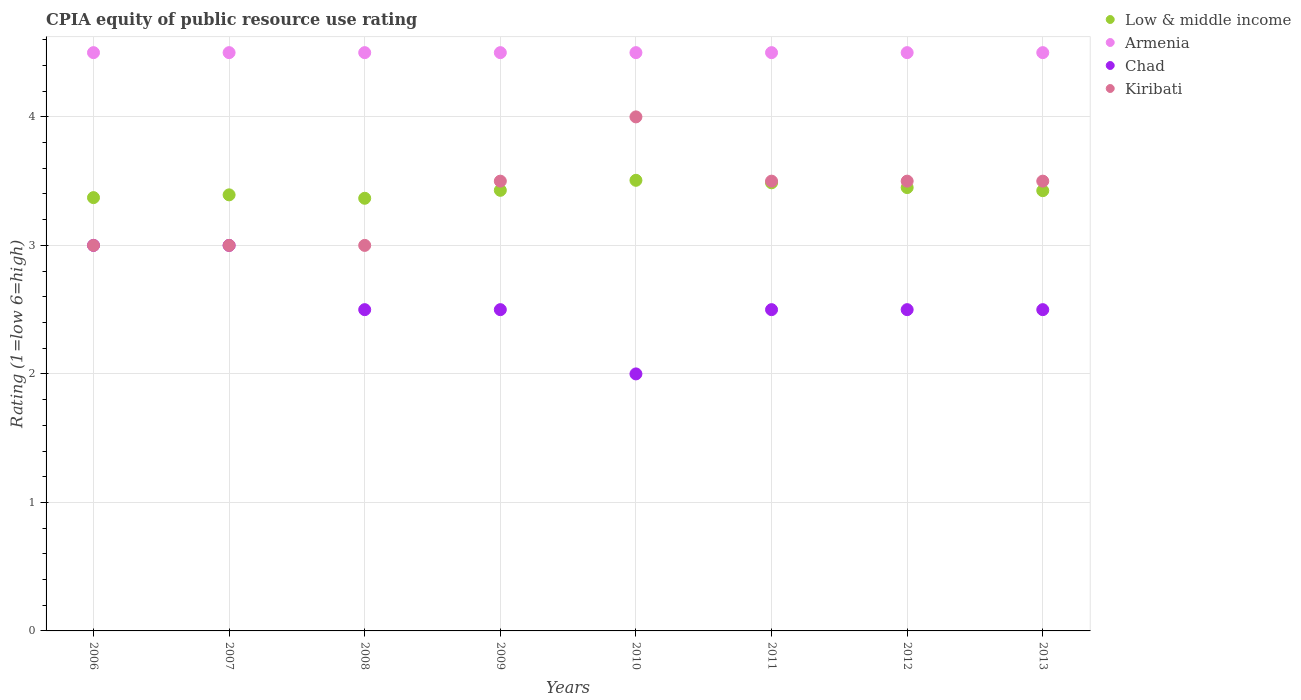Is the number of dotlines equal to the number of legend labels?
Make the answer very short. Yes. What is the CPIA rating in Armenia in 2008?
Provide a short and direct response. 4.5. Across all years, what is the minimum CPIA rating in Low & middle income?
Make the answer very short. 3.37. What is the total CPIA rating in Chad in the graph?
Offer a terse response. 20.5. What is the difference between the CPIA rating in Kiribati in 2011 and the CPIA rating in Low & middle income in 2012?
Keep it short and to the point. 0.05. What is the average CPIA rating in Kiribati per year?
Provide a succinct answer. 3.38. In the year 2011, what is the difference between the CPIA rating in Armenia and CPIA rating in Low & middle income?
Your response must be concise. 1.01. In how many years, is the CPIA rating in Armenia greater than 1.6?
Provide a succinct answer. 8. What is the ratio of the CPIA rating in Armenia in 2012 to that in 2013?
Give a very brief answer. 1. Is the CPIA rating in Kiribati in 2008 less than that in 2012?
Make the answer very short. Yes. What is the difference between the highest and the second highest CPIA rating in Low & middle income?
Your answer should be very brief. 0.02. What is the difference between the highest and the lowest CPIA rating in Kiribati?
Make the answer very short. 1. Is the sum of the CPIA rating in Chad in 2007 and 2008 greater than the maximum CPIA rating in Armenia across all years?
Offer a very short reply. Yes. Is it the case that in every year, the sum of the CPIA rating in Kiribati and CPIA rating in Armenia  is greater than the CPIA rating in Low & middle income?
Offer a very short reply. Yes. Is the CPIA rating in Armenia strictly greater than the CPIA rating in Low & middle income over the years?
Keep it short and to the point. Yes. Is the CPIA rating in Kiribati strictly less than the CPIA rating in Low & middle income over the years?
Make the answer very short. No. What is the difference between two consecutive major ticks on the Y-axis?
Provide a short and direct response. 1. Does the graph contain any zero values?
Ensure brevity in your answer.  No. Does the graph contain grids?
Your response must be concise. Yes. How many legend labels are there?
Your response must be concise. 4. What is the title of the graph?
Your answer should be very brief. CPIA equity of public resource use rating. What is the label or title of the X-axis?
Offer a terse response. Years. What is the label or title of the Y-axis?
Offer a very short reply. Rating (1=low 6=high). What is the Rating (1=low 6=high) in Low & middle income in 2006?
Provide a short and direct response. 3.37. What is the Rating (1=low 6=high) of Armenia in 2006?
Ensure brevity in your answer.  4.5. What is the Rating (1=low 6=high) in Kiribati in 2006?
Offer a terse response. 3. What is the Rating (1=low 6=high) of Low & middle income in 2007?
Provide a short and direct response. 3.39. What is the Rating (1=low 6=high) in Armenia in 2007?
Give a very brief answer. 4.5. What is the Rating (1=low 6=high) in Chad in 2007?
Offer a very short reply. 3. What is the Rating (1=low 6=high) of Low & middle income in 2008?
Your answer should be very brief. 3.37. What is the Rating (1=low 6=high) of Armenia in 2008?
Your answer should be very brief. 4.5. What is the Rating (1=low 6=high) in Chad in 2008?
Offer a very short reply. 2.5. What is the Rating (1=low 6=high) of Low & middle income in 2009?
Give a very brief answer. 3.43. What is the Rating (1=low 6=high) of Kiribati in 2009?
Provide a succinct answer. 3.5. What is the Rating (1=low 6=high) of Low & middle income in 2010?
Your answer should be very brief. 3.51. What is the Rating (1=low 6=high) of Low & middle income in 2011?
Provide a short and direct response. 3.49. What is the Rating (1=low 6=high) of Chad in 2011?
Keep it short and to the point. 2.5. What is the Rating (1=low 6=high) in Low & middle income in 2012?
Your response must be concise. 3.45. What is the Rating (1=low 6=high) of Chad in 2012?
Provide a succinct answer. 2.5. What is the Rating (1=low 6=high) of Low & middle income in 2013?
Ensure brevity in your answer.  3.43. What is the Rating (1=low 6=high) of Kiribati in 2013?
Keep it short and to the point. 3.5. Across all years, what is the maximum Rating (1=low 6=high) in Low & middle income?
Your answer should be compact. 3.51. Across all years, what is the maximum Rating (1=low 6=high) of Armenia?
Give a very brief answer. 4.5. Across all years, what is the maximum Rating (1=low 6=high) in Kiribati?
Offer a terse response. 4. Across all years, what is the minimum Rating (1=low 6=high) of Low & middle income?
Your response must be concise. 3.37. Across all years, what is the minimum Rating (1=low 6=high) in Armenia?
Offer a terse response. 4.5. Across all years, what is the minimum Rating (1=low 6=high) in Kiribati?
Make the answer very short. 3. What is the total Rating (1=low 6=high) of Low & middle income in the graph?
Your answer should be very brief. 27.43. What is the total Rating (1=low 6=high) in Armenia in the graph?
Provide a succinct answer. 36. What is the total Rating (1=low 6=high) in Chad in the graph?
Provide a succinct answer. 20.5. What is the total Rating (1=low 6=high) in Kiribati in the graph?
Make the answer very short. 27. What is the difference between the Rating (1=low 6=high) in Low & middle income in 2006 and that in 2007?
Your answer should be very brief. -0.02. What is the difference between the Rating (1=low 6=high) in Armenia in 2006 and that in 2007?
Ensure brevity in your answer.  0. What is the difference between the Rating (1=low 6=high) of Chad in 2006 and that in 2007?
Keep it short and to the point. 0. What is the difference between the Rating (1=low 6=high) of Low & middle income in 2006 and that in 2008?
Your answer should be very brief. 0.01. What is the difference between the Rating (1=low 6=high) in Armenia in 2006 and that in 2008?
Provide a short and direct response. 0. What is the difference between the Rating (1=low 6=high) of Kiribati in 2006 and that in 2008?
Ensure brevity in your answer.  0. What is the difference between the Rating (1=low 6=high) in Low & middle income in 2006 and that in 2009?
Provide a succinct answer. -0.06. What is the difference between the Rating (1=low 6=high) in Armenia in 2006 and that in 2009?
Provide a short and direct response. 0. What is the difference between the Rating (1=low 6=high) in Kiribati in 2006 and that in 2009?
Your answer should be compact. -0.5. What is the difference between the Rating (1=low 6=high) of Low & middle income in 2006 and that in 2010?
Your answer should be compact. -0.13. What is the difference between the Rating (1=low 6=high) of Armenia in 2006 and that in 2010?
Your answer should be compact. 0. What is the difference between the Rating (1=low 6=high) of Chad in 2006 and that in 2010?
Offer a terse response. 1. What is the difference between the Rating (1=low 6=high) in Kiribati in 2006 and that in 2010?
Offer a very short reply. -1. What is the difference between the Rating (1=low 6=high) in Low & middle income in 2006 and that in 2011?
Offer a very short reply. -0.12. What is the difference between the Rating (1=low 6=high) of Chad in 2006 and that in 2011?
Your response must be concise. 0.5. What is the difference between the Rating (1=low 6=high) of Low & middle income in 2006 and that in 2012?
Keep it short and to the point. -0.08. What is the difference between the Rating (1=low 6=high) in Chad in 2006 and that in 2012?
Offer a very short reply. 0.5. What is the difference between the Rating (1=low 6=high) in Kiribati in 2006 and that in 2012?
Your answer should be compact. -0.5. What is the difference between the Rating (1=low 6=high) in Low & middle income in 2006 and that in 2013?
Make the answer very short. -0.05. What is the difference between the Rating (1=low 6=high) in Armenia in 2006 and that in 2013?
Offer a terse response. 0. What is the difference between the Rating (1=low 6=high) in Kiribati in 2006 and that in 2013?
Keep it short and to the point. -0.5. What is the difference between the Rating (1=low 6=high) in Low & middle income in 2007 and that in 2008?
Provide a succinct answer. 0.03. What is the difference between the Rating (1=low 6=high) of Armenia in 2007 and that in 2008?
Your answer should be compact. 0. What is the difference between the Rating (1=low 6=high) in Chad in 2007 and that in 2008?
Offer a very short reply. 0.5. What is the difference between the Rating (1=low 6=high) in Kiribati in 2007 and that in 2008?
Offer a terse response. 0. What is the difference between the Rating (1=low 6=high) in Low & middle income in 2007 and that in 2009?
Offer a very short reply. -0.04. What is the difference between the Rating (1=low 6=high) of Armenia in 2007 and that in 2009?
Give a very brief answer. 0. What is the difference between the Rating (1=low 6=high) of Chad in 2007 and that in 2009?
Keep it short and to the point. 0.5. What is the difference between the Rating (1=low 6=high) in Kiribati in 2007 and that in 2009?
Your response must be concise. -0.5. What is the difference between the Rating (1=low 6=high) in Low & middle income in 2007 and that in 2010?
Offer a very short reply. -0.11. What is the difference between the Rating (1=low 6=high) in Chad in 2007 and that in 2010?
Offer a very short reply. 1. What is the difference between the Rating (1=low 6=high) in Kiribati in 2007 and that in 2010?
Your response must be concise. -1. What is the difference between the Rating (1=low 6=high) of Low & middle income in 2007 and that in 2011?
Ensure brevity in your answer.  -0.09. What is the difference between the Rating (1=low 6=high) of Low & middle income in 2007 and that in 2012?
Your answer should be compact. -0.06. What is the difference between the Rating (1=low 6=high) of Armenia in 2007 and that in 2012?
Give a very brief answer. 0. What is the difference between the Rating (1=low 6=high) in Kiribati in 2007 and that in 2012?
Give a very brief answer. -0.5. What is the difference between the Rating (1=low 6=high) in Low & middle income in 2007 and that in 2013?
Give a very brief answer. -0.03. What is the difference between the Rating (1=low 6=high) in Chad in 2007 and that in 2013?
Make the answer very short. 0.5. What is the difference between the Rating (1=low 6=high) of Low & middle income in 2008 and that in 2009?
Offer a very short reply. -0.06. What is the difference between the Rating (1=low 6=high) of Armenia in 2008 and that in 2009?
Your answer should be very brief. 0. What is the difference between the Rating (1=low 6=high) in Kiribati in 2008 and that in 2009?
Your answer should be very brief. -0.5. What is the difference between the Rating (1=low 6=high) in Low & middle income in 2008 and that in 2010?
Provide a short and direct response. -0.14. What is the difference between the Rating (1=low 6=high) in Chad in 2008 and that in 2010?
Keep it short and to the point. 0.5. What is the difference between the Rating (1=low 6=high) in Kiribati in 2008 and that in 2010?
Provide a succinct answer. -1. What is the difference between the Rating (1=low 6=high) in Low & middle income in 2008 and that in 2011?
Make the answer very short. -0.12. What is the difference between the Rating (1=low 6=high) in Armenia in 2008 and that in 2011?
Provide a short and direct response. 0. What is the difference between the Rating (1=low 6=high) in Kiribati in 2008 and that in 2011?
Your answer should be compact. -0.5. What is the difference between the Rating (1=low 6=high) of Low & middle income in 2008 and that in 2012?
Your answer should be compact. -0.08. What is the difference between the Rating (1=low 6=high) of Chad in 2008 and that in 2012?
Keep it short and to the point. 0. What is the difference between the Rating (1=low 6=high) of Low & middle income in 2008 and that in 2013?
Provide a short and direct response. -0.06. What is the difference between the Rating (1=low 6=high) of Low & middle income in 2009 and that in 2010?
Give a very brief answer. -0.08. What is the difference between the Rating (1=low 6=high) in Kiribati in 2009 and that in 2010?
Provide a succinct answer. -0.5. What is the difference between the Rating (1=low 6=high) in Low & middle income in 2009 and that in 2011?
Offer a very short reply. -0.06. What is the difference between the Rating (1=low 6=high) of Armenia in 2009 and that in 2011?
Provide a short and direct response. 0. What is the difference between the Rating (1=low 6=high) in Low & middle income in 2009 and that in 2012?
Your answer should be very brief. -0.02. What is the difference between the Rating (1=low 6=high) in Chad in 2009 and that in 2012?
Ensure brevity in your answer.  0. What is the difference between the Rating (1=low 6=high) of Kiribati in 2009 and that in 2012?
Provide a short and direct response. 0. What is the difference between the Rating (1=low 6=high) of Low & middle income in 2009 and that in 2013?
Provide a short and direct response. 0. What is the difference between the Rating (1=low 6=high) in Armenia in 2009 and that in 2013?
Offer a very short reply. 0. What is the difference between the Rating (1=low 6=high) in Chad in 2009 and that in 2013?
Keep it short and to the point. 0. What is the difference between the Rating (1=low 6=high) of Low & middle income in 2010 and that in 2011?
Provide a short and direct response. 0.02. What is the difference between the Rating (1=low 6=high) of Chad in 2010 and that in 2011?
Provide a short and direct response. -0.5. What is the difference between the Rating (1=low 6=high) in Kiribati in 2010 and that in 2011?
Provide a short and direct response. 0.5. What is the difference between the Rating (1=low 6=high) of Low & middle income in 2010 and that in 2012?
Ensure brevity in your answer.  0.06. What is the difference between the Rating (1=low 6=high) in Armenia in 2010 and that in 2012?
Provide a short and direct response. 0. What is the difference between the Rating (1=low 6=high) of Kiribati in 2010 and that in 2012?
Provide a short and direct response. 0.5. What is the difference between the Rating (1=low 6=high) in Low & middle income in 2010 and that in 2013?
Ensure brevity in your answer.  0.08. What is the difference between the Rating (1=low 6=high) of Armenia in 2010 and that in 2013?
Keep it short and to the point. 0. What is the difference between the Rating (1=low 6=high) of Chad in 2010 and that in 2013?
Keep it short and to the point. -0.5. What is the difference between the Rating (1=low 6=high) of Low & middle income in 2011 and that in 2012?
Your answer should be compact. 0.04. What is the difference between the Rating (1=low 6=high) of Armenia in 2011 and that in 2012?
Keep it short and to the point. 0. What is the difference between the Rating (1=low 6=high) of Low & middle income in 2011 and that in 2013?
Offer a very short reply. 0.06. What is the difference between the Rating (1=low 6=high) of Armenia in 2011 and that in 2013?
Keep it short and to the point. 0. What is the difference between the Rating (1=low 6=high) in Chad in 2011 and that in 2013?
Give a very brief answer. 0. What is the difference between the Rating (1=low 6=high) of Low & middle income in 2012 and that in 2013?
Offer a very short reply. 0.02. What is the difference between the Rating (1=low 6=high) of Chad in 2012 and that in 2013?
Give a very brief answer. 0. What is the difference between the Rating (1=low 6=high) in Kiribati in 2012 and that in 2013?
Your response must be concise. 0. What is the difference between the Rating (1=low 6=high) of Low & middle income in 2006 and the Rating (1=low 6=high) of Armenia in 2007?
Your response must be concise. -1.13. What is the difference between the Rating (1=low 6=high) in Low & middle income in 2006 and the Rating (1=low 6=high) in Chad in 2007?
Give a very brief answer. 0.37. What is the difference between the Rating (1=low 6=high) of Low & middle income in 2006 and the Rating (1=low 6=high) of Kiribati in 2007?
Ensure brevity in your answer.  0.37. What is the difference between the Rating (1=low 6=high) of Armenia in 2006 and the Rating (1=low 6=high) of Chad in 2007?
Offer a terse response. 1.5. What is the difference between the Rating (1=low 6=high) of Low & middle income in 2006 and the Rating (1=low 6=high) of Armenia in 2008?
Your answer should be very brief. -1.13. What is the difference between the Rating (1=low 6=high) in Low & middle income in 2006 and the Rating (1=low 6=high) in Chad in 2008?
Keep it short and to the point. 0.87. What is the difference between the Rating (1=low 6=high) in Low & middle income in 2006 and the Rating (1=low 6=high) in Kiribati in 2008?
Give a very brief answer. 0.37. What is the difference between the Rating (1=low 6=high) in Armenia in 2006 and the Rating (1=low 6=high) in Kiribati in 2008?
Your answer should be very brief. 1.5. What is the difference between the Rating (1=low 6=high) in Low & middle income in 2006 and the Rating (1=low 6=high) in Armenia in 2009?
Offer a terse response. -1.13. What is the difference between the Rating (1=low 6=high) of Low & middle income in 2006 and the Rating (1=low 6=high) of Chad in 2009?
Offer a very short reply. 0.87. What is the difference between the Rating (1=low 6=high) in Low & middle income in 2006 and the Rating (1=low 6=high) in Kiribati in 2009?
Your answer should be very brief. -0.13. What is the difference between the Rating (1=low 6=high) in Armenia in 2006 and the Rating (1=low 6=high) in Chad in 2009?
Make the answer very short. 2. What is the difference between the Rating (1=low 6=high) in Armenia in 2006 and the Rating (1=low 6=high) in Kiribati in 2009?
Give a very brief answer. 1. What is the difference between the Rating (1=low 6=high) of Chad in 2006 and the Rating (1=low 6=high) of Kiribati in 2009?
Ensure brevity in your answer.  -0.5. What is the difference between the Rating (1=low 6=high) in Low & middle income in 2006 and the Rating (1=low 6=high) in Armenia in 2010?
Offer a terse response. -1.13. What is the difference between the Rating (1=low 6=high) of Low & middle income in 2006 and the Rating (1=low 6=high) of Chad in 2010?
Keep it short and to the point. 1.37. What is the difference between the Rating (1=low 6=high) of Low & middle income in 2006 and the Rating (1=low 6=high) of Kiribati in 2010?
Your response must be concise. -0.63. What is the difference between the Rating (1=low 6=high) in Armenia in 2006 and the Rating (1=low 6=high) in Kiribati in 2010?
Ensure brevity in your answer.  0.5. What is the difference between the Rating (1=low 6=high) of Chad in 2006 and the Rating (1=low 6=high) of Kiribati in 2010?
Your response must be concise. -1. What is the difference between the Rating (1=low 6=high) in Low & middle income in 2006 and the Rating (1=low 6=high) in Armenia in 2011?
Offer a very short reply. -1.13. What is the difference between the Rating (1=low 6=high) of Low & middle income in 2006 and the Rating (1=low 6=high) of Chad in 2011?
Keep it short and to the point. 0.87. What is the difference between the Rating (1=low 6=high) in Low & middle income in 2006 and the Rating (1=low 6=high) in Kiribati in 2011?
Give a very brief answer. -0.13. What is the difference between the Rating (1=low 6=high) in Armenia in 2006 and the Rating (1=low 6=high) in Chad in 2011?
Offer a terse response. 2. What is the difference between the Rating (1=low 6=high) in Armenia in 2006 and the Rating (1=low 6=high) in Kiribati in 2011?
Offer a terse response. 1. What is the difference between the Rating (1=low 6=high) in Chad in 2006 and the Rating (1=low 6=high) in Kiribati in 2011?
Make the answer very short. -0.5. What is the difference between the Rating (1=low 6=high) in Low & middle income in 2006 and the Rating (1=low 6=high) in Armenia in 2012?
Your response must be concise. -1.13. What is the difference between the Rating (1=low 6=high) in Low & middle income in 2006 and the Rating (1=low 6=high) in Chad in 2012?
Your response must be concise. 0.87. What is the difference between the Rating (1=low 6=high) of Low & middle income in 2006 and the Rating (1=low 6=high) of Kiribati in 2012?
Ensure brevity in your answer.  -0.13. What is the difference between the Rating (1=low 6=high) of Armenia in 2006 and the Rating (1=low 6=high) of Chad in 2012?
Offer a terse response. 2. What is the difference between the Rating (1=low 6=high) in Low & middle income in 2006 and the Rating (1=low 6=high) in Armenia in 2013?
Your answer should be compact. -1.13. What is the difference between the Rating (1=low 6=high) of Low & middle income in 2006 and the Rating (1=low 6=high) of Chad in 2013?
Offer a terse response. 0.87. What is the difference between the Rating (1=low 6=high) of Low & middle income in 2006 and the Rating (1=low 6=high) of Kiribati in 2013?
Ensure brevity in your answer.  -0.13. What is the difference between the Rating (1=low 6=high) of Armenia in 2006 and the Rating (1=low 6=high) of Kiribati in 2013?
Your answer should be very brief. 1. What is the difference between the Rating (1=low 6=high) in Chad in 2006 and the Rating (1=low 6=high) in Kiribati in 2013?
Your answer should be very brief. -0.5. What is the difference between the Rating (1=low 6=high) in Low & middle income in 2007 and the Rating (1=low 6=high) in Armenia in 2008?
Your answer should be compact. -1.11. What is the difference between the Rating (1=low 6=high) in Low & middle income in 2007 and the Rating (1=low 6=high) in Chad in 2008?
Make the answer very short. 0.89. What is the difference between the Rating (1=low 6=high) of Low & middle income in 2007 and the Rating (1=low 6=high) of Kiribati in 2008?
Your answer should be compact. 0.39. What is the difference between the Rating (1=low 6=high) of Low & middle income in 2007 and the Rating (1=low 6=high) of Armenia in 2009?
Make the answer very short. -1.11. What is the difference between the Rating (1=low 6=high) of Low & middle income in 2007 and the Rating (1=low 6=high) of Chad in 2009?
Offer a terse response. 0.89. What is the difference between the Rating (1=low 6=high) of Low & middle income in 2007 and the Rating (1=low 6=high) of Kiribati in 2009?
Keep it short and to the point. -0.11. What is the difference between the Rating (1=low 6=high) of Armenia in 2007 and the Rating (1=low 6=high) of Chad in 2009?
Keep it short and to the point. 2. What is the difference between the Rating (1=low 6=high) of Low & middle income in 2007 and the Rating (1=low 6=high) of Armenia in 2010?
Provide a short and direct response. -1.11. What is the difference between the Rating (1=low 6=high) of Low & middle income in 2007 and the Rating (1=low 6=high) of Chad in 2010?
Offer a terse response. 1.39. What is the difference between the Rating (1=low 6=high) of Low & middle income in 2007 and the Rating (1=low 6=high) of Kiribati in 2010?
Your response must be concise. -0.61. What is the difference between the Rating (1=low 6=high) of Armenia in 2007 and the Rating (1=low 6=high) of Kiribati in 2010?
Keep it short and to the point. 0.5. What is the difference between the Rating (1=low 6=high) of Low & middle income in 2007 and the Rating (1=low 6=high) of Armenia in 2011?
Your response must be concise. -1.11. What is the difference between the Rating (1=low 6=high) of Low & middle income in 2007 and the Rating (1=low 6=high) of Chad in 2011?
Your response must be concise. 0.89. What is the difference between the Rating (1=low 6=high) in Low & middle income in 2007 and the Rating (1=low 6=high) in Kiribati in 2011?
Provide a succinct answer. -0.11. What is the difference between the Rating (1=low 6=high) of Armenia in 2007 and the Rating (1=low 6=high) of Kiribati in 2011?
Ensure brevity in your answer.  1. What is the difference between the Rating (1=low 6=high) of Low & middle income in 2007 and the Rating (1=low 6=high) of Armenia in 2012?
Provide a succinct answer. -1.11. What is the difference between the Rating (1=low 6=high) of Low & middle income in 2007 and the Rating (1=low 6=high) of Chad in 2012?
Offer a very short reply. 0.89. What is the difference between the Rating (1=low 6=high) in Low & middle income in 2007 and the Rating (1=low 6=high) in Kiribati in 2012?
Offer a terse response. -0.11. What is the difference between the Rating (1=low 6=high) in Armenia in 2007 and the Rating (1=low 6=high) in Chad in 2012?
Your answer should be very brief. 2. What is the difference between the Rating (1=low 6=high) of Armenia in 2007 and the Rating (1=low 6=high) of Kiribati in 2012?
Provide a succinct answer. 1. What is the difference between the Rating (1=low 6=high) in Chad in 2007 and the Rating (1=low 6=high) in Kiribati in 2012?
Provide a short and direct response. -0.5. What is the difference between the Rating (1=low 6=high) of Low & middle income in 2007 and the Rating (1=low 6=high) of Armenia in 2013?
Ensure brevity in your answer.  -1.11. What is the difference between the Rating (1=low 6=high) in Low & middle income in 2007 and the Rating (1=low 6=high) in Chad in 2013?
Your answer should be compact. 0.89. What is the difference between the Rating (1=low 6=high) of Low & middle income in 2007 and the Rating (1=low 6=high) of Kiribati in 2013?
Make the answer very short. -0.11. What is the difference between the Rating (1=low 6=high) of Armenia in 2007 and the Rating (1=low 6=high) of Chad in 2013?
Ensure brevity in your answer.  2. What is the difference between the Rating (1=low 6=high) in Low & middle income in 2008 and the Rating (1=low 6=high) in Armenia in 2009?
Your response must be concise. -1.13. What is the difference between the Rating (1=low 6=high) of Low & middle income in 2008 and the Rating (1=low 6=high) of Chad in 2009?
Your answer should be very brief. 0.87. What is the difference between the Rating (1=low 6=high) in Low & middle income in 2008 and the Rating (1=low 6=high) in Kiribati in 2009?
Ensure brevity in your answer.  -0.13. What is the difference between the Rating (1=low 6=high) of Low & middle income in 2008 and the Rating (1=low 6=high) of Armenia in 2010?
Your response must be concise. -1.13. What is the difference between the Rating (1=low 6=high) of Low & middle income in 2008 and the Rating (1=low 6=high) of Chad in 2010?
Your answer should be very brief. 1.37. What is the difference between the Rating (1=low 6=high) in Low & middle income in 2008 and the Rating (1=low 6=high) in Kiribati in 2010?
Make the answer very short. -0.63. What is the difference between the Rating (1=low 6=high) in Armenia in 2008 and the Rating (1=low 6=high) in Kiribati in 2010?
Provide a short and direct response. 0.5. What is the difference between the Rating (1=low 6=high) in Chad in 2008 and the Rating (1=low 6=high) in Kiribati in 2010?
Offer a terse response. -1.5. What is the difference between the Rating (1=low 6=high) of Low & middle income in 2008 and the Rating (1=low 6=high) of Armenia in 2011?
Provide a succinct answer. -1.13. What is the difference between the Rating (1=low 6=high) in Low & middle income in 2008 and the Rating (1=low 6=high) in Chad in 2011?
Provide a short and direct response. 0.87. What is the difference between the Rating (1=low 6=high) of Low & middle income in 2008 and the Rating (1=low 6=high) of Kiribati in 2011?
Provide a short and direct response. -0.13. What is the difference between the Rating (1=low 6=high) of Chad in 2008 and the Rating (1=low 6=high) of Kiribati in 2011?
Keep it short and to the point. -1. What is the difference between the Rating (1=low 6=high) in Low & middle income in 2008 and the Rating (1=low 6=high) in Armenia in 2012?
Provide a short and direct response. -1.13. What is the difference between the Rating (1=low 6=high) of Low & middle income in 2008 and the Rating (1=low 6=high) of Chad in 2012?
Keep it short and to the point. 0.87. What is the difference between the Rating (1=low 6=high) of Low & middle income in 2008 and the Rating (1=low 6=high) of Kiribati in 2012?
Your response must be concise. -0.13. What is the difference between the Rating (1=low 6=high) of Low & middle income in 2008 and the Rating (1=low 6=high) of Armenia in 2013?
Your answer should be very brief. -1.13. What is the difference between the Rating (1=low 6=high) in Low & middle income in 2008 and the Rating (1=low 6=high) in Chad in 2013?
Ensure brevity in your answer.  0.87. What is the difference between the Rating (1=low 6=high) in Low & middle income in 2008 and the Rating (1=low 6=high) in Kiribati in 2013?
Offer a terse response. -0.13. What is the difference between the Rating (1=low 6=high) in Armenia in 2008 and the Rating (1=low 6=high) in Chad in 2013?
Provide a succinct answer. 2. What is the difference between the Rating (1=low 6=high) in Chad in 2008 and the Rating (1=low 6=high) in Kiribati in 2013?
Make the answer very short. -1. What is the difference between the Rating (1=low 6=high) in Low & middle income in 2009 and the Rating (1=low 6=high) in Armenia in 2010?
Make the answer very short. -1.07. What is the difference between the Rating (1=low 6=high) of Low & middle income in 2009 and the Rating (1=low 6=high) of Chad in 2010?
Provide a succinct answer. 1.43. What is the difference between the Rating (1=low 6=high) of Low & middle income in 2009 and the Rating (1=low 6=high) of Kiribati in 2010?
Offer a terse response. -0.57. What is the difference between the Rating (1=low 6=high) in Armenia in 2009 and the Rating (1=low 6=high) in Chad in 2010?
Provide a succinct answer. 2.5. What is the difference between the Rating (1=low 6=high) in Low & middle income in 2009 and the Rating (1=low 6=high) in Armenia in 2011?
Keep it short and to the point. -1.07. What is the difference between the Rating (1=low 6=high) in Low & middle income in 2009 and the Rating (1=low 6=high) in Chad in 2011?
Your answer should be very brief. 0.93. What is the difference between the Rating (1=low 6=high) in Low & middle income in 2009 and the Rating (1=low 6=high) in Kiribati in 2011?
Give a very brief answer. -0.07. What is the difference between the Rating (1=low 6=high) in Armenia in 2009 and the Rating (1=low 6=high) in Kiribati in 2011?
Provide a short and direct response. 1. What is the difference between the Rating (1=low 6=high) in Chad in 2009 and the Rating (1=low 6=high) in Kiribati in 2011?
Provide a short and direct response. -1. What is the difference between the Rating (1=low 6=high) in Low & middle income in 2009 and the Rating (1=low 6=high) in Armenia in 2012?
Your response must be concise. -1.07. What is the difference between the Rating (1=low 6=high) of Low & middle income in 2009 and the Rating (1=low 6=high) of Chad in 2012?
Offer a very short reply. 0.93. What is the difference between the Rating (1=low 6=high) in Low & middle income in 2009 and the Rating (1=low 6=high) in Kiribati in 2012?
Ensure brevity in your answer.  -0.07. What is the difference between the Rating (1=low 6=high) of Low & middle income in 2009 and the Rating (1=low 6=high) of Armenia in 2013?
Keep it short and to the point. -1.07. What is the difference between the Rating (1=low 6=high) in Low & middle income in 2009 and the Rating (1=low 6=high) in Kiribati in 2013?
Ensure brevity in your answer.  -0.07. What is the difference between the Rating (1=low 6=high) in Armenia in 2009 and the Rating (1=low 6=high) in Kiribati in 2013?
Keep it short and to the point. 1. What is the difference between the Rating (1=low 6=high) in Chad in 2009 and the Rating (1=low 6=high) in Kiribati in 2013?
Keep it short and to the point. -1. What is the difference between the Rating (1=low 6=high) in Low & middle income in 2010 and the Rating (1=low 6=high) in Armenia in 2011?
Your answer should be very brief. -0.99. What is the difference between the Rating (1=low 6=high) of Low & middle income in 2010 and the Rating (1=low 6=high) of Chad in 2011?
Keep it short and to the point. 1.01. What is the difference between the Rating (1=low 6=high) of Low & middle income in 2010 and the Rating (1=low 6=high) of Kiribati in 2011?
Your answer should be compact. 0.01. What is the difference between the Rating (1=low 6=high) of Armenia in 2010 and the Rating (1=low 6=high) of Chad in 2011?
Ensure brevity in your answer.  2. What is the difference between the Rating (1=low 6=high) in Armenia in 2010 and the Rating (1=low 6=high) in Kiribati in 2011?
Your response must be concise. 1. What is the difference between the Rating (1=low 6=high) in Chad in 2010 and the Rating (1=low 6=high) in Kiribati in 2011?
Ensure brevity in your answer.  -1.5. What is the difference between the Rating (1=low 6=high) in Low & middle income in 2010 and the Rating (1=low 6=high) in Armenia in 2012?
Ensure brevity in your answer.  -0.99. What is the difference between the Rating (1=low 6=high) of Low & middle income in 2010 and the Rating (1=low 6=high) of Chad in 2012?
Offer a terse response. 1.01. What is the difference between the Rating (1=low 6=high) in Low & middle income in 2010 and the Rating (1=low 6=high) in Kiribati in 2012?
Give a very brief answer. 0.01. What is the difference between the Rating (1=low 6=high) in Chad in 2010 and the Rating (1=low 6=high) in Kiribati in 2012?
Provide a short and direct response. -1.5. What is the difference between the Rating (1=low 6=high) of Low & middle income in 2010 and the Rating (1=low 6=high) of Armenia in 2013?
Give a very brief answer. -0.99. What is the difference between the Rating (1=low 6=high) of Low & middle income in 2010 and the Rating (1=low 6=high) of Kiribati in 2013?
Give a very brief answer. 0.01. What is the difference between the Rating (1=low 6=high) of Chad in 2010 and the Rating (1=low 6=high) of Kiribati in 2013?
Provide a short and direct response. -1.5. What is the difference between the Rating (1=low 6=high) of Low & middle income in 2011 and the Rating (1=low 6=high) of Armenia in 2012?
Make the answer very short. -1.01. What is the difference between the Rating (1=low 6=high) in Low & middle income in 2011 and the Rating (1=low 6=high) in Chad in 2012?
Offer a very short reply. 0.99. What is the difference between the Rating (1=low 6=high) in Low & middle income in 2011 and the Rating (1=low 6=high) in Kiribati in 2012?
Your response must be concise. -0.01. What is the difference between the Rating (1=low 6=high) of Chad in 2011 and the Rating (1=low 6=high) of Kiribati in 2012?
Provide a succinct answer. -1. What is the difference between the Rating (1=low 6=high) of Low & middle income in 2011 and the Rating (1=low 6=high) of Armenia in 2013?
Ensure brevity in your answer.  -1.01. What is the difference between the Rating (1=low 6=high) in Low & middle income in 2011 and the Rating (1=low 6=high) in Chad in 2013?
Offer a terse response. 0.99. What is the difference between the Rating (1=low 6=high) in Low & middle income in 2011 and the Rating (1=low 6=high) in Kiribati in 2013?
Offer a very short reply. -0.01. What is the difference between the Rating (1=low 6=high) of Armenia in 2011 and the Rating (1=low 6=high) of Chad in 2013?
Offer a very short reply. 2. What is the difference between the Rating (1=low 6=high) in Armenia in 2011 and the Rating (1=low 6=high) in Kiribati in 2013?
Offer a terse response. 1. What is the difference between the Rating (1=low 6=high) in Chad in 2011 and the Rating (1=low 6=high) in Kiribati in 2013?
Offer a terse response. -1. What is the difference between the Rating (1=low 6=high) of Low & middle income in 2012 and the Rating (1=low 6=high) of Armenia in 2013?
Keep it short and to the point. -1.05. What is the difference between the Rating (1=low 6=high) of Low & middle income in 2012 and the Rating (1=low 6=high) of Chad in 2013?
Keep it short and to the point. 0.95. What is the difference between the Rating (1=low 6=high) in Armenia in 2012 and the Rating (1=low 6=high) in Chad in 2013?
Offer a very short reply. 2. What is the difference between the Rating (1=low 6=high) in Armenia in 2012 and the Rating (1=low 6=high) in Kiribati in 2013?
Your answer should be very brief. 1. What is the difference between the Rating (1=low 6=high) of Chad in 2012 and the Rating (1=low 6=high) of Kiribati in 2013?
Your response must be concise. -1. What is the average Rating (1=low 6=high) of Low & middle income per year?
Make the answer very short. 3.43. What is the average Rating (1=low 6=high) in Chad per year?
Your response must be concise. 2.56. What is the average Rating (1=low 6=high) of Kiribati per year?
Provide a succinct answer. 3.38. In the year 2006, what is the difference between the Rating (1=low 6=high) of Low & middle income and Rating (1=low 6=high) of Armenia?
Your answer should be very brief. -1.13. In the year 2006, what is the difference between the Rating (1=low 6=high) in Low & middle income and Rating (1=low 6=high) in Chad?
Your answer should be compact. 0.37. In the year 2006, what is the difference between the Rating (1=low 6=high) in Low & middle income and Rating (1=low 6=high) in Kiribati?
Provide a succinct answer. 0.37. In the year 2007, what is the difference between the Rating (1=low 6=high) in Low & middle income and Rating (1=low 6=high) in Armenia?
Offer a terse response. -1.11. In the year 2007, what is the difference between the Rating (1=low 6=high) in Low & middle income and Rating (1=low 6=high) in Chad?
Ensure brevity in your answer.  0.39. In the year 2007, what is the difference between the Rating (1=low 6=high) of Low & middle income and Rating (1=low 6=high) of Kiribati?
Your answer should be compact. 0.39. In the year 2007, what is the difference between the Rating (1=low 6=high) in Armenia and Rating (1=low 6=high) in Chad?
Your response must be concise. 1.5. In the year 2007, what is the difference between the Rating (1=low 6=high) of Armenia and Rating (1=low 6=high) of Kiribati?
Ensure brevity in your answer.  1.5. In the year 2008, what is the difference between the Rating (1=low 6=high) in Low & middle income and Rating (1=low 6=high) in Armenia?
Make the answer very short. -1.13. In the year 2008, what is the difference between the Rating (1=low 6=high) of Low & middle income and Rating (1=low 6=high) of Chad?
Your answer should be very brief. 0.87. In the year 2008, what is the difference between the Rating (1=low 6=high) of Low & middle income and Rating (1=low 6=high) of Kiribati?
Give a very brief answer. 0.37. In the year 2008, what is the difference between the Rating (1=low 6=high) in Armenia and Rating (1=low 6=high) in Chad?
Provide a succinct answer. 2. In the year 2008, what is the difference between the Rating (1=low 6=high) of Chad and Rating (1=low 6=high) of Kiribati?
Offer a very short reply. -0.5. In the year 2009, what is the difference between the Rating (1=low 6=high) of Low & middle income and Rating (1=low 6=high) of Armenia?
Make the answer very short. -1.07. In the year 2009, what is the difference between the Rating (1=low 6=high) in Low & middle income and Rating (1=low 6=high) in Kiribati?
Make the answer very short. -0.07. In the year 2009, what is the difference between the Rating (1=low 6=high) in Armenia and Rating (1=low 6=high) in Kiribati?
Make the answer very short. 1. In the year 2010, what is the difference between the Rating (1=low 6=high) of Low & middle income and Rating (1=low 6=high) of Armenia?
Your response must be concise. -0.99. In the year 2010, what is the difference between the Rating (1=low 6=high) of Low & middle income and Rating (1=low 6=high) of Chad?
Your response must be concise. 1.51. In the year 2010, what is the difference between the Rating (1=low 6=high) in Low & middle income and Rating (1=low 6=high) in Kiribati?
Make the answer very short. -0.49. In the year 2010, what is the difference between the Rating (1=low 6=high) in Armenia and Rating (1=low 6=high) in Kiribati?
Your answer should be compact. 0.5. In the year 2010, what is the difference between the Rating (1=low 6=high) in Chad and Rating (1=low 6=high) in Kiribati?
Keep it short and to the point. -2. In the year 2011, what is the difference between the Rating (1=low 6=high) of Low & middle income and Rating (1=low 6=high) of Armenia?
Keep it short and to the point. -1.01. In the year 2011, what is the difference between the Rating (1=low 6=high) in Low & middle income and Rating (1=low 6=high) in Chad?
Offer a very short reply. 0.99. In the year 2011, what is the difference between the Rating (1=low 6=high) of Low & middle income and Rating (1=low 6=high) of Kiribati?
Provide a short and direct response. -0.01. In the year 2011, what is the difference between the Rating (1=low 6=high) of Chad and Rating (1=low 6=high) of Kiribati?
Make the answer very short. -1. In the year 2012, what is the difference between the Rating (1=low 6=high) in Low & middle income and Rating (1=low 6=high) in Armenia?
Give a very brief answer. -1.05. In the year 2012, what is the difference between the Rating (1=low 6=high) in Low & middle income and Rating (1=low 6=high) in Kiribati?
Give a very brief answer. -0.05. In the year 2012, what is the difference between the Rating (1=low 6=high) of Armenia and Rating (1=low 6=high) of Chad?
Make the answer very short. 2. In the year 2012, what is the difference between the Rating (1=low 6=high) in Chad and Rating (1=low 6=high) in Kiribati?
Your answer should be compact. -1. In the year 2013, what is the difference between the Rating (1=low 6=high) in Low & middle income and Rating (1=low 6=high) in Armenia?
Give a very brief answer. -1.07. In the year 2013, what is the difference between the Rating (1=low 6=high) in Low & middle income and Rating (1=low 6=high) in Chad?
Ensure brevity in your answer.  0.93. In the year 2013, what is the difference between the Rating (1=low 6=high) of Low & middle income and Rating (1=low 6=high) of Kiribati?
Your answer should be very brief. -0.07. In the year 2013, what is the difference between the Rating (1=low 6=high) in Armenia and Rating (1=low 6=high) in Chad?
Your response must be concise. 2. In the year 2013, what is the difference between the Rating (1=low 6=high) in Armenia and Rating (1=low 6=high) in Kiribati?
Keep it short and to the point. 1. What is the ratio of the Rating (1=low 6=high) of Low & middle income in 2006 to that in 2007?
Ensure brevity in your answer.  0.99. What is the ratio of the Rating (1=low 6=high) of Armenia in 2006 to that in 2007?
Your answer should be compact. 1. What is the ratio of the Rating (1=low 6=high) of Chad in 2006 to that in 2007?
Offer a terse response. 1. What is the ratio of the Rating (1=low 6=high) in Low & middle income in 2006 to that in 2008?
Ensure brevity in your answer.  1. What is the ratio of the Rating (1=low 6=high) of Armenia in 2006 to that in 2008?
Ensure brevity in your answer.  1. What is the ratio of the Rating (1=low 6=high) of Chad in 2006 to that in 2008?
Make the answer very short. 1.2. What is the ratio of the Rating (1=low 6=high) in Kiribati in 2006 to that in 2008?
Your response must be concise. 1. What is the ratio of the Rating (1=low 6=high) of Low & middle income in 2006 to that in 2009?
Offer a terse response. 0.98. What is the ratio of the Rating (1=low 6=high) of Armenia in 2006 to that in 2009?
Offer a terse response. 1. What is the ratio of the Rating (1=low 6=high) in Low & middle income in 2006 to that in 2010?
Keep it short and to the point. 0.96. What is the ratio of the Rating (1=low 6=high) of Armenia in 2006 to that in 2010?
Your answer should be very brief. 1. What is the ratio of the Rating (1=low 6=high) in Kiribati in 2006 to that in 2010?
Make the answer very short. 0.75. What is the ratio of the Rating (1=low 6=high) in Low & middle income in 2006 to that in 2011?
Make the answer very short. 0.97. What is the ratio of the Rating (1=low 6=high) of Armenia in 2006 to that in 2011?
Your answer should be compact. 1. What is the ratio of the Rating (1=low 6=high) in Chad in 2006 to that in 2011?
Ensure brevity in your answer.  1.2. What is the ratio of the Rating (1=low 6=high) of Low & middle income in 2006 to that in 2012?
Provide a short and direct response. 0.98. What is the ratio of the Rating (1=low 6=high) in Armenia in 2006 to that in 2012?
Your response must be concise. 1. What is the ratio of the Rating (1=low 6=high) in Chad in 2006 to that in 2012?
Your response must be concise. 1.2. What is the ratio of the Rating (1=low 6=high) in Kiribati in 2006 to that in 2012?
Provide a short and direct response. 0.86. What is the ratio of the Rating (1=low 6=high) of Low & middle income in 2006 to that in 2013?
Your answer should be very brief. 0.98. What is the ratio of the Rating (1=low 6=high) of Kiribati in 2006 to that in 2013?
Keep it short and to the point. 0.86. What is the ratio of the Rating (1=low 6=high) in Low & middle income in 2007 to that in 2008?
Keep it short and to the point. 1.01. What is the ratio of the Rating (1=low 6=high) of Kiribati in 2007 to that in 2008?
Your answer should be very brief. 1. What is the ratio of the Rating (1=low 6=high) in Low & middle income in 2007 to that in 2009?
Your answer should be very brief. 0.99. What is the ratio of the Rating (1=low 6=high) in Chad in 2007 to that in 2009?
Keep it short and to the point. 1.2. What is the ratio of the Rating (1=low 6=high) in Low & middle income in 2007 to that in 2010?
Keep it short and to the point. 0.97. What is the ratio of the Rating (1=low 6=high) in Armenia in 2007 to that in 2010?
Provide a short and direct response. 1. What is the ratio of the Rating (1=low 6=high) of Chad in 2007 to that in 2010?
Your answer should be compact. 1.5. What is the ratio of the Rating (1=low 6=high) of Low & middle income in 2007 to that in 2011?
Offer a terse response. 0.97. What is the ratio of the Rating (1=low 6=high) of Armenia in 2007 to that in 2011?
Provide a short and direct response. 1. What is the ratio of the Rating (1=low 6=high) in Chad in 2007 to that in 2011?
Offer a very short reply. 1.2. What is the ratio of the Rating (1=low 6=high) in Kiribati in 2007 to that in 2011?
Offer a terse response. 0.86. What is the ratio of the Rating (1=low 6=high) of Low & middle income in 2007 to that in 2012?
Offer a terse response. 0.98. What is the ratio of the Rating (1=low 6=high) in Armenia in 2007 to that in 2012?
Give a very brief answer. 1. What is the ratio of the Rating (1=low 6=high) of Chad in 2007 to that in 2012?
Make the answer very short. 1.2. What is the ratio of the Rating (1=low 6=high) of Kiribati in 2007 to that in 2012?
Make the answer very short. 0.86. What is the ratio of the Rating (1=low 6=high) in Low & middle income in 2007 to that in 2013?
Make the answer very short. 0.99. What is the ratio of the Rating (1=low 6=high) of Armenia in 2007 to that in 2013?
Make the answer very short. 1. What is the ratio of the Rating (1=low 6=high) in Chad in 2007 to that in 2013?
Your response must be concise. 1.2. What is the ratio of the Rating (1=low 6=high) in Low & middle income in 2008 to that in 2009?
Offer a terse response. 0.98. What is the ratio of the Rating (1=low 6=high) of Armenia in 2008 to that in 2009?
Give a very brief answer. 1. What is the ratio of the Rating (1=low 6=high) of Chad in 2008 to that in 2009?
Make the answer very short. 1. What is the ratio of the Rating (1=low 6=high) in Low & middle income in 2008 to that in 2010?
Provide a short and direct response. 0.96. What is the ratio of the Rating (1=low 6=high) in Chad in 2008 to that in 2010?
Your response must be concise. 1.25. What is the ratio of the Rating (1=low 6=high) of Low & middle income in 2008 to that in 2011?
Keep it short and to the point. 0.97. What is the ratio of the Rating (1=low 6=high) in Chad in 2008 to that in 2011?
Provide a short and direct response. 1. What is the ratio of the Rating (1=low 6=high) in Low & middle income in 2008 to that in 2012?
Make the answer very short. 0.98. What is the ratio of the Rating (1=low 6=high) of Armenia in 2008 to that in 2012?
Your answer should be very brief. 1. What is the ratio of the Rating (1=low 6=high) of Chad in 2008 to that in 2012?
Keep it short and to the point. 1. What is the ratio of the Rating (1=low 6=high) of Kiribati in 2008 to that in 2012?
Your answer should be compact. 0.86. What is the ratio of the Rating (1=low 6=high) in Low & middle income in 2008 to that in 2013?
Your answer should be compact. 0.98. What is the ratio of the Rating (1=low 6=high) of Kiribati in 2008 to that in 2013?
Offer a terse response. 0.86. What is the ratio of the Rating (1=low 6=high) of Low & middle income in 2009 to that in 2010?
Keep it short and to the point. 0.98. What is the ratio of the Rating (1=low 6=high) in Chad in 2009 to that in 2010?
Provide a succinct answer. 1.25. What is the ratio of the Rating (1=low 6=high) of Low & middle income in 2009 to that in 2011?
Your answer should be very brief. 0.98. What is the ratio of the Rating (1=low 6=high) of Armenia in 2009 to that in 2011?
Make the answer very short. 1. What is the ratio of the Rating (1=low 6=high) in Low & middle income in 2009 to that in 2012?
Keep it short and to the point. 0.99. What is the ratio of the Rating (1=low 6=high) in Chad in 2009 to that in 2012?
Ensure brevity in your answer.  1. What is the ratio of the Rating (1=low 6=high) of Kiribati in 2009 to that in 2012?
Ensure brevity in your answer.  1. What is the ratio of the Rating (1=low 6=high) in Armenia in 2009 to that in 2013?
Offer a terse response. 1. What is the ratio of the Rating (1=low 6=high) of Kiribati in 2009 to that in 2013?
Offer a terse response. 1. What is the ratio of the Rating (1=low 6=high) of Low & middle income in 2010 to that in 2011?
Offer a very short reply. 1.01. What is the ratio of the Rating (1=low 6=high) in Armenia in 2010 to that in 2011?
Your answer should be very brief. 1. What is the ratio of the Rating (1=low 6=high) in Low & middle income in 2010 to that in 2012?
Make the answer very short. 1.02. What is the ratio of the Rating (1=low 6=high) in Chad in 2010 to that in 2012?
Keep it short and to the point. 0.8. What is the ratio of the Rating (1=low 6=high) of Kiribati in 2010 to that in 2012?
Provide a succinct answer. 1.14. What is the ratio of the Rating (1=low 6=high) in Low & middle income in 2010 to that in 2013?
Your answer should be compact. 1.02. What is the ratio of the Rating (1=low 6=high) of Armenia in 2010 to that in 2013?
Provide a succinct answer. 1. What is the ratio of the Rating (1=low 6=high) in Kiribati in 2010 to that in 2013?
Offer a very short reply. 1.14. What is the ratio of the Rating (1=low 6=high) of Low & middle income in 2011 to that in 2012?
Your answer should be very brief. 1.01. What is the ratio of the Rating (1=low 6=high) of Armenia in 2011 to that in 2012?
Offer a terse response. 1. What is the ratio of the Rating (1=low 6=high) in Chad in 2011 to that in 2012?
Give a very brief answer. 1. What is the ratio of the Rating (1=low 6=high) in Kiribati in 2011 to that in 2012?
Make the answer very short. 1. What is the ratio of the Rating (1=low 6=high) of Low & middle income in 2011 to that in 2013?
Give a very brief answer. 1.02. What is the ratio of the Rating (1=low 6=high) in Kiribati in 2011 to that in 2013?
Keep it short and to the point. 1. What is the ratio of the Rating (1=low 6=high) of Chad in 2012 to that in 2013?
Provide a succinct answer. 1. What is the difference between the highest and the second highest Rating (1=low 6=high) in Low & middle income?
Your answer should be compact. 0.02. What is the difference between the highest and the second highest Rating (1=low 6=high) of Chad?
Your answer should be very brief. 0. What is the difference between the highest and the second highest Rating (1=low 6=high) in Kiribati?
Give a very brief answer. 0.5. What is the difference between the highest and the lowest Rating (1=low 6=high) of Low & middle income?
Provide a short and direct response. 0.14. 